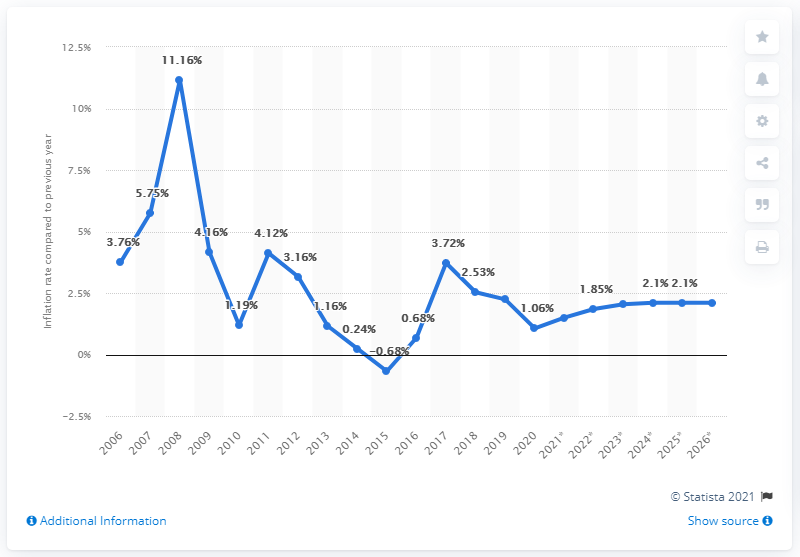Point out several critical features in this image. In 2020, the inflation rate in Lithuania was 1.06%. 